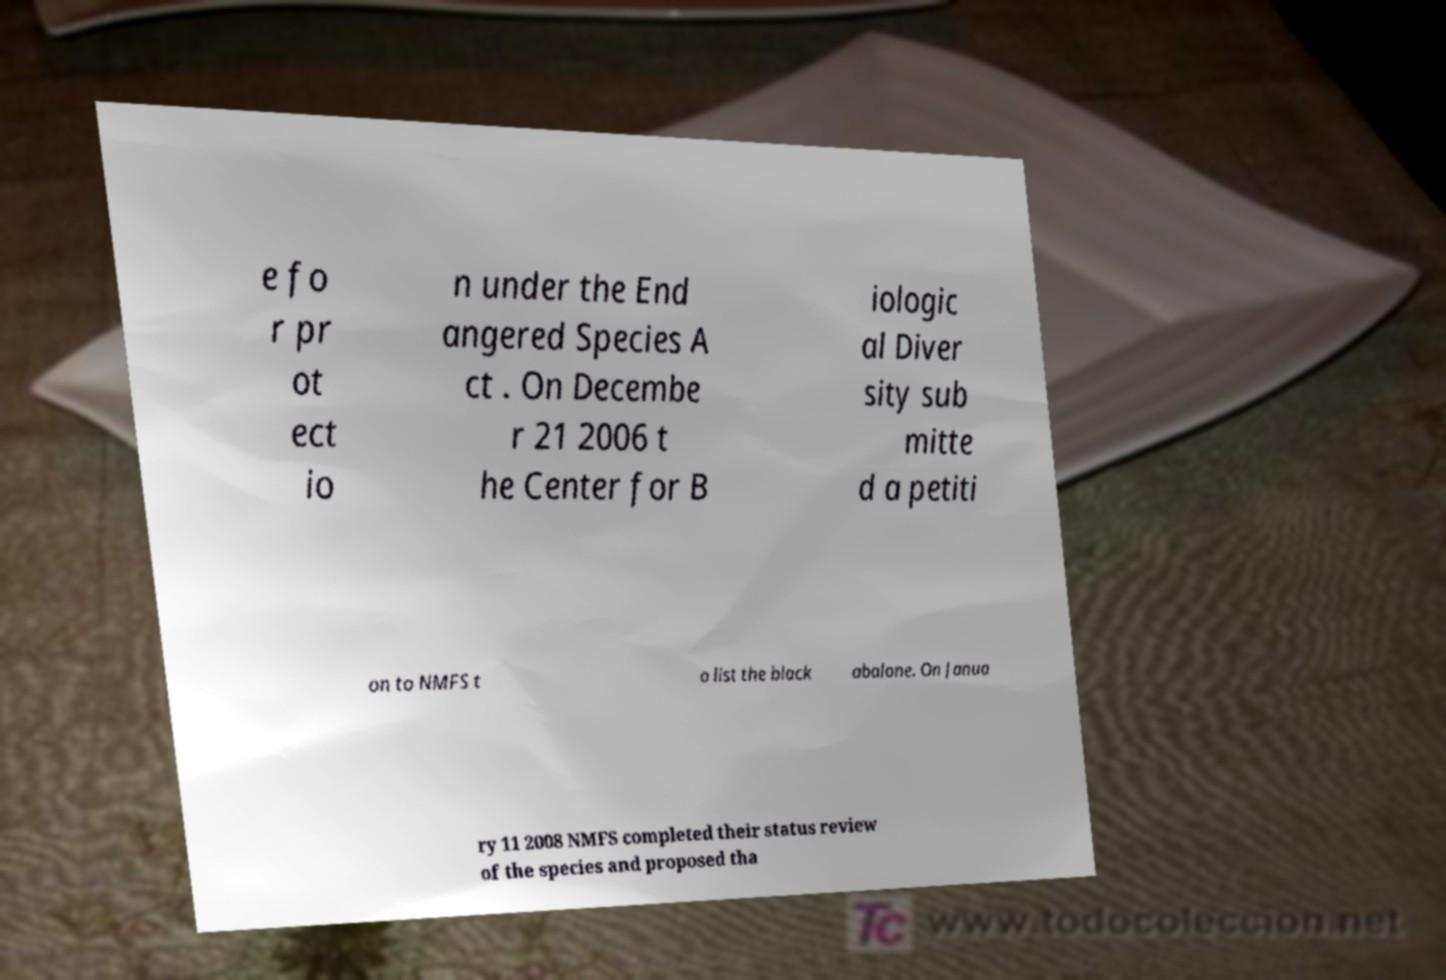Please read and relay the text visible in this image. What does it say? e fo r pr ot ect io n under the End angered Species A ct . On Decembe r 21 2006 t he Center for B iologic al Diver sity sub mitte d a petiti on to NMFS t o list the black abalone. On Janua ry 11 2008 NMFS completed their status review of the species and proposed tha 